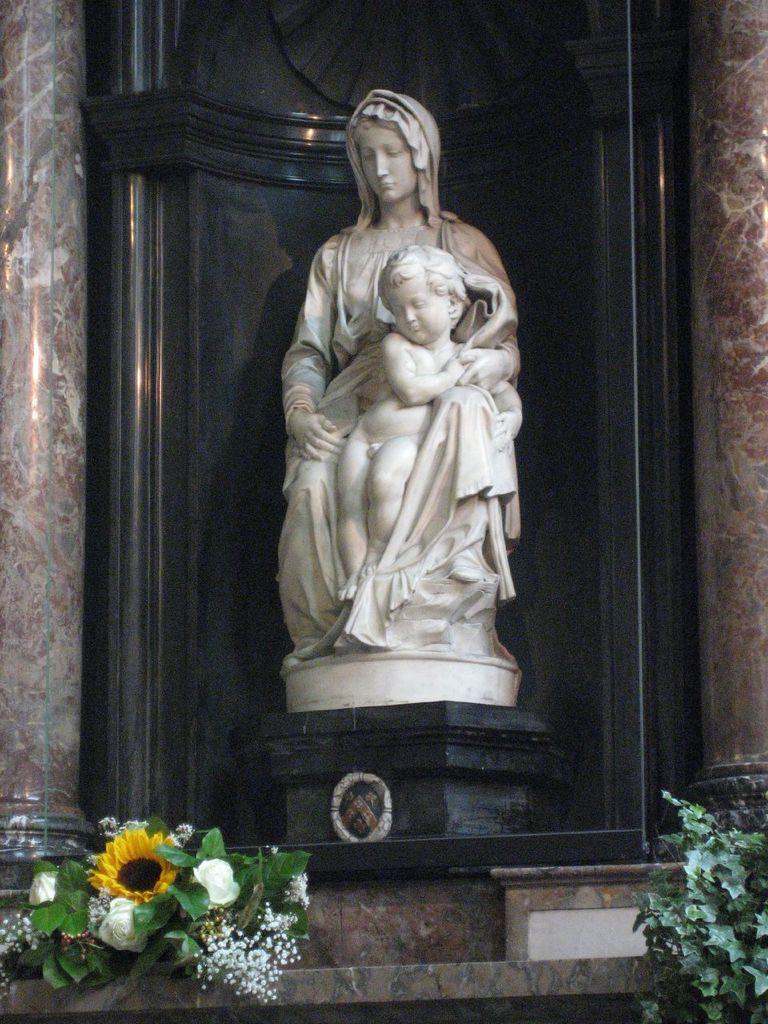How would you summarize this image in a sentence or two? In this picture we can see flowers, leaves, statue and beside this statue we can see pillars. 